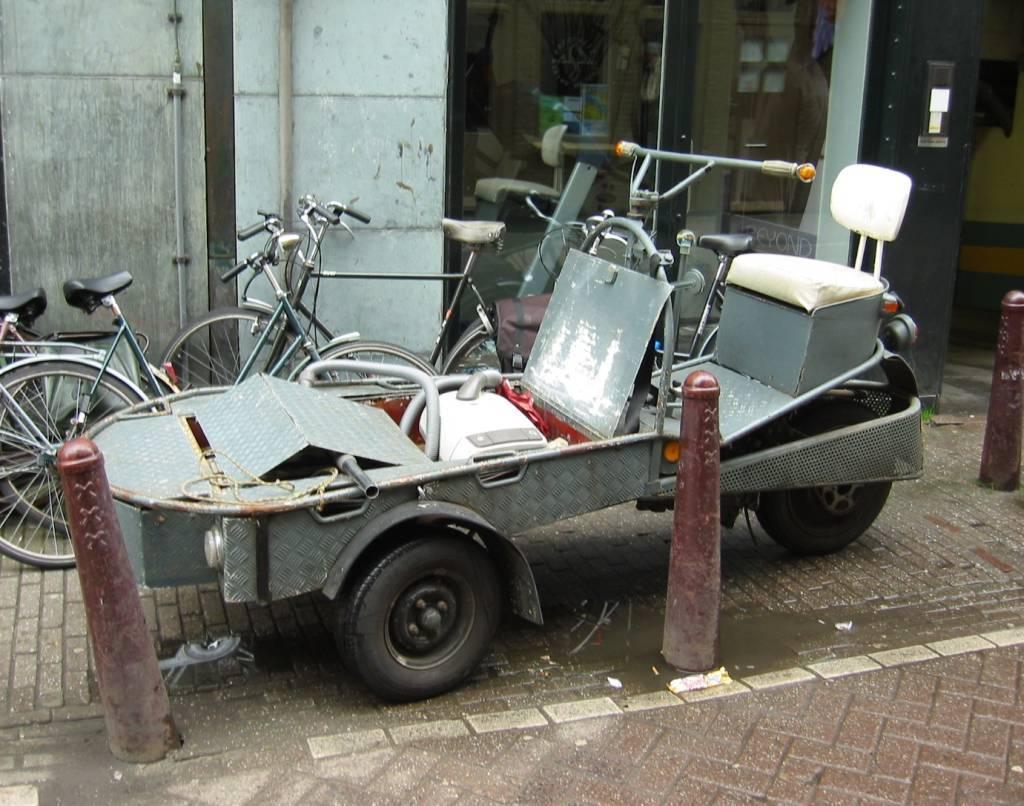Please provide a concise description of this image. In this image I can see a motor cycle and bicycles kept on the road and I can see the wall and pipes. 